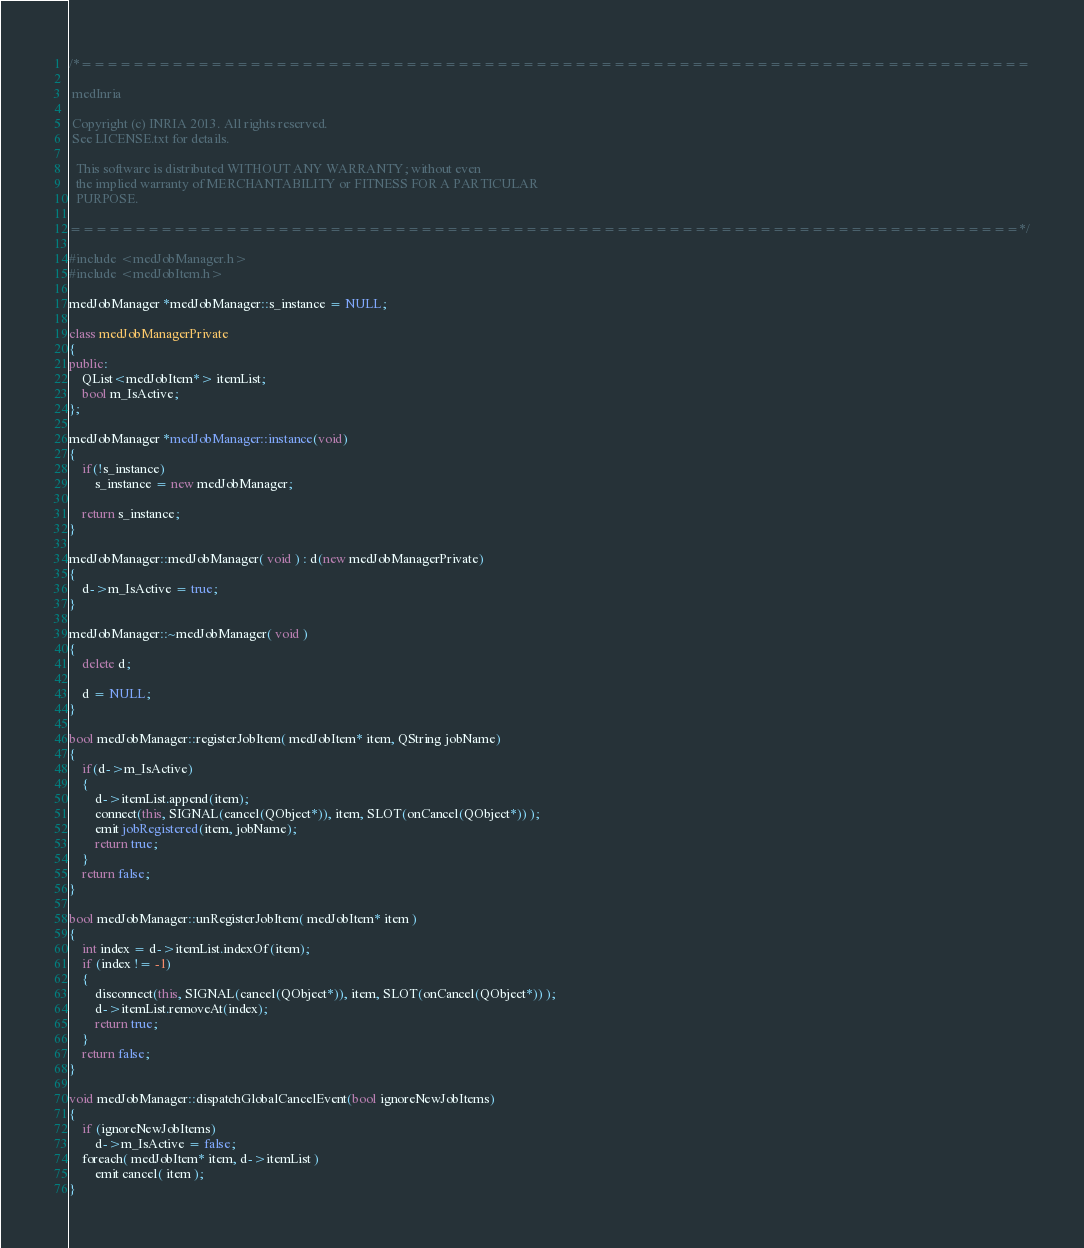Convert code to text. <code><loc_0><loc_0><loc_500><loc_500><_C++_>/*=========================================================================

 medInria

 Copyright (c) INRIA 2013. All rights reserved.
 See LICENSE.txt for details.
 
  This software is distributed WITHOUT ANY WARRANTY; without even
  the implied warranty of MERCHANTABILITY or FITNESS FOR A PARTICULAR
  PURPOSE.

=========================================================================*/

#include <medJobManager.h>
#include <medJobItem.h>

medJobManager *medJobManager::s_instance = NULL;

class medJobManagerPrivate
{
public:
    QList<medJobItem*> itemList;
    bool m_IsActive;
};

medJobManager *medJobManager::instance(void)
{
    if(!s_instance)
        s_instance = new medJobManager;

    return s_instance;
}

medJobManager::medJobManager( void ) : d(new medJobManagerPrivate)
{
    d->m_IsActive = true;
}

medJobManager::~medJobManager( void )
{
    delete d;

    d = NULL;
}

bool medJobManager::registerJobItem( medJobItem* item, QString jobName)
{
    if(d->m_IsActive)
    {
        d->itemList.append(item);
        connect(this, SIGNAL(cancel(QObject*)), item, SLOT(onCancel(QObject*)) );
        emit jobRegistered(item, jobName);
        return true;
    }
    return false;
}

bool medJobManager::unRegisterJobItem( medJobItem* item )
{
    int index = d->itemList.indexOf(item);
    if (index != -1)
    {
        disconnect(this, SIGNAL(cancel(QObject*)), item, SLOT(onCancel(QObject*)) );
        d->itemList.removeAt(index);
        return true;
    }
    return false;
}

void medJobManager::dispatchGlobalCancelEvent(bool ignoreNewJobItems)
{
    if (ignoreNewJobItems)
        d->m_IsActive = false;
    foreach( medJobItem* item, d->itemList )
        emit cancel( item );
}
</code> 